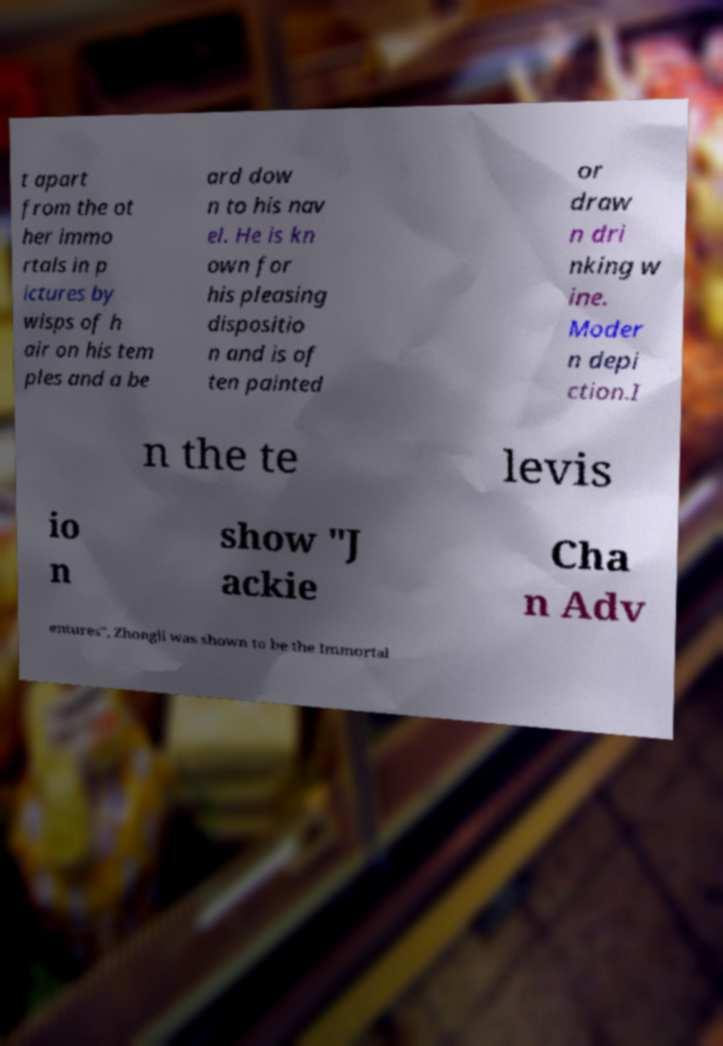Please read and relay the text visible in this image. What does it say? t apart from the ot her immo rtals in p ictures by wisps of h air on his tem ples and a be ard dow n to his nav el. He is kn own for his pleasing dispositio n and is of ten painted or draw n dri nking w ine. Moder n depi ction.I n the te levis io n show "J ackie Cha n Adv entures", Zhongli was shown to be the Immortal 